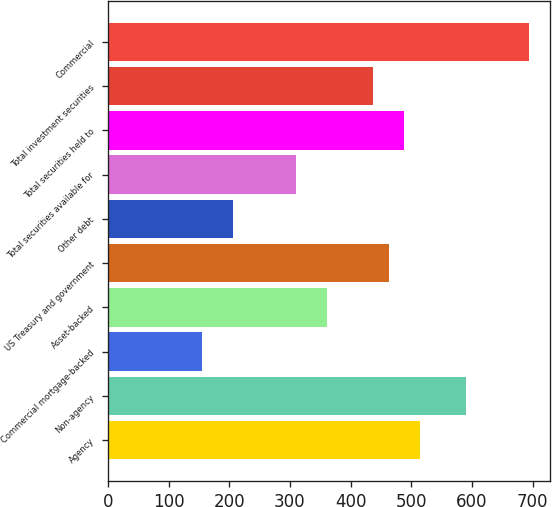<chart> <loc_0><loc_0><loc_500><loc_500><bar_chart><fcel>Agency<fcel>Non-agency<fcel>Commercial mortgage-backed<fcel>Asset-backed<fcel>US Treasury and government<fcel>Other debt<fcel>Total securities available for<fcel>Total securities held to<fcel>Total investment securities<fcel>Commercial<nl><fcel>514<fcel>590.8<fcel>155.6<fcel>360.4<fcel>462.8<fcel>206.8<fcel>309.2<fcel>488.4<fcel>437.2<fcel>693.2<nl></chart> 